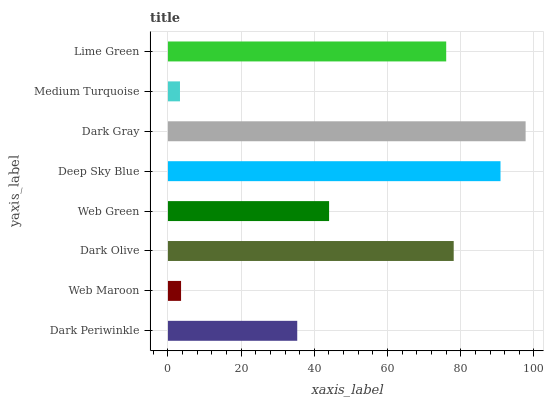Is Medium Turquoise the minimum?
Answer yes or no. Yes. Is Dark Gray the maximum?
Answer yes or no. Yes. Is Web Maroon the minimum?
Answer yes or no. No. Is Web Maroon the maximum?
Answer yes or no. No. Is Dark Periwinkle greater than Web Maroon?
Answer yes or no. Yes. Is Web Maroon less than Dark Periwinkle?
Answer yes or no. Yes. Is Web Maroon greater than Dark Periwinkle?
Answer yes or no. No. Is Dark Periwinkle less than Web Maroon?
Answer yes or no. No. Is Lime Green the high median?
Answer yes or no. Yes. Is Web Green the low median?
Answer yes or no. Yes. Is Deep Sky Blue the high median?
Answer yes or no. No. Is Dark Periwinkle the low median?
Answer yes or no. No. 